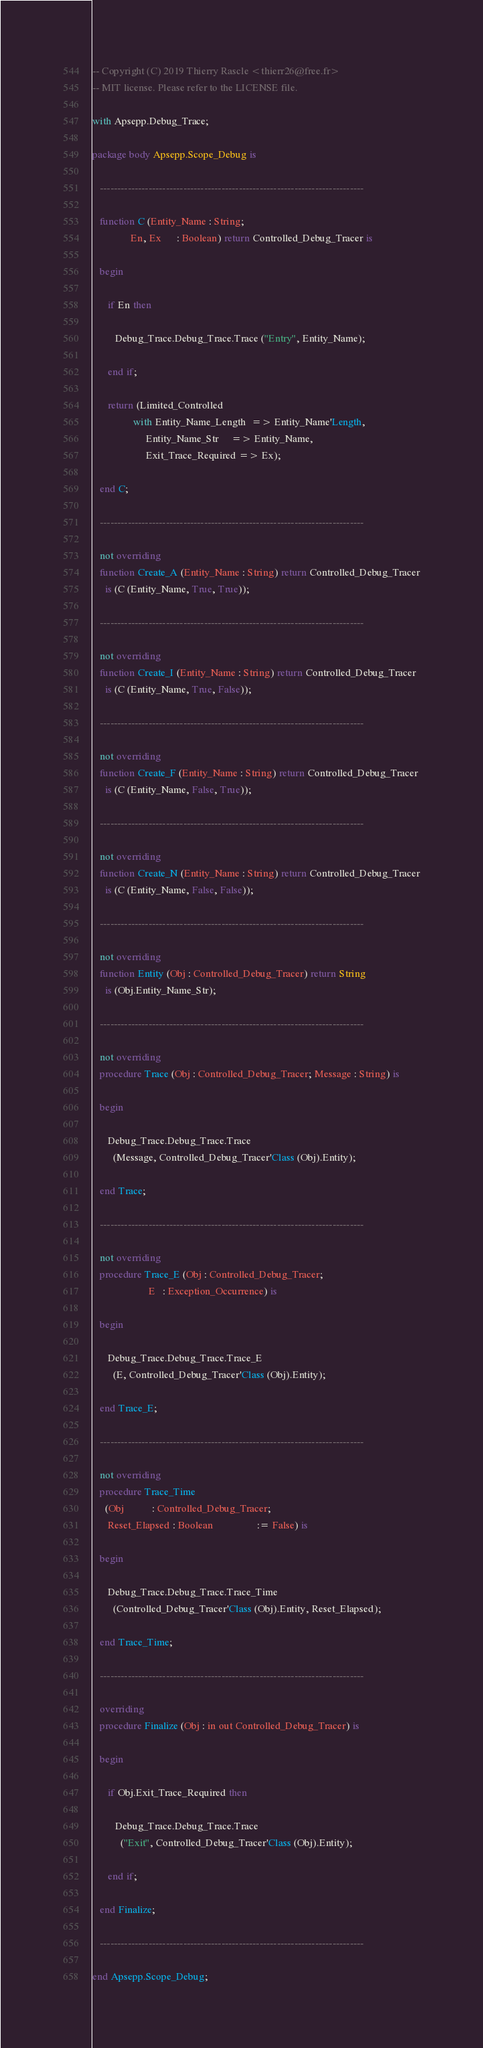Convert code to text. <code><loc_0><loc_0><loc_500><loc_500><_Ada_>-- Copyright (C) 2019 Thierry Rascle <thierr26@free.fr>
-- MIT license. Please refer to the LICENSE file.

with Apsepp.Debug_Trace;

package body Apsepp.Scope_Debug is

   ----------------------------------------------------------------------------

   function C (Entity_Name : String;
               En, Ex      : Boolean) return Controlled_Debug_Tracer is

   begin

      if En then

         Debug_Trace.Debug_Trace.Trace ("Entry", Entity_Name);

      end if;

      return (Limited_Controlled
                with Entity_Name_Length  => Entity_Name'Length,
                     Entity_Name_Str     => Entity_Name,
                     Exit_Trace_Required => Ex);

   end C;

   ----------------------------------------------------------------------------

   not overriding
   function Create_A (Entity_Name : String) return Controlled_Debug_Tracer
     is (C (Entity_Name, True, True));

   ----------------------------------------------------------------------------

   not overriding
   function Create_I (Entity_Name : String) return Controlled_Debug_Tracer
     is (C (Entity_Name, True, False));

   ----------------------------------------------------------------------------

   not overriding
   function Create_F (Entity_Name : String) return Controlled_Debug_Tracer
     is (C (Entity_Name, False, True));

   ----------------------------------------------------------------------------

   not overriding
   function Create_N (Entity_Name : String) return Controlled_Debug_Tracer
     is (C (Entity_Name, False, False));

   ----------------------------------------------------------------------------

   not overriding
   function Entity (Obj : Controlled_Debug_Tracer) return String
     is (Obj.Entity_Name_Str);

   ----------------------------------------------------------------------------

   not overriding
   procedure Trace (Obj : Controlled_Debug_Tracer; Message : String) is

   begin

      Debug_Trace.Debug_Trace.Trace
        (Message, Controlled_Debug_Tracer'Class (Obj).Entity);

   end Trace;

   ----------------------------------------------------------------------------

   not overriding
   procedure Trace_E (Obj : Controlled_Debug_Tracer;
                      E   : Exception_Occurrence) is

   begin

      Debug_Trace.Debug_Trace.Trace_E
        (E, Controlled_Debug_Tracer'Class (Obj).Entity);

   end Trace_E;

   ----------------------------------------------------------------------------

   not overriding
   procedure Trace_Time
     (Obj           : Controlled_Debug_Tracer;
      Reset_Elapsed : Boolean                 := False) is

   begin

      Debug_Trace.Debug_Trace.Trace_Time
        (Controlled_Debug_Tracer'Class (Obj).Entity, Reset_Elapsed);

   end Trace_Time;

   ----------------------------------------------------------------------------

   overriding
   procedure Finalize (Obj : in out Controlled_Debug_Tracer) is

   begin

      if Obj.Exit_Trace_Required then

         Debug_Trace.Debug_Trace.Trace
           ("Exit", Controlled_Debug_Tracer'Class (Obj).Entity);

      end if;

   end Finalize;

   ----------------------------------------------------------------------------

end Apsepp.Scope_Debug;
</code> 